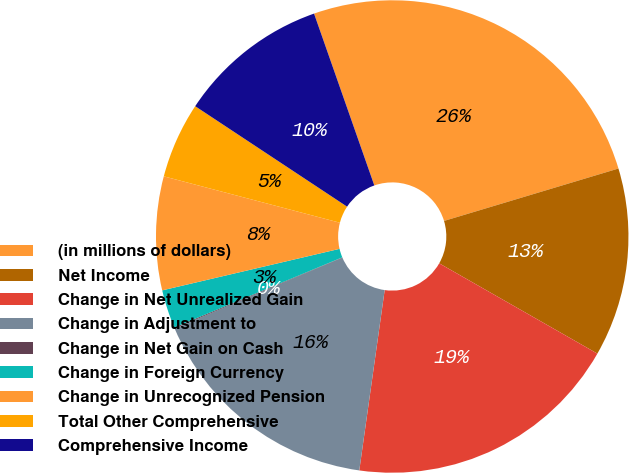Convert chart. <chart><loc_0><loc_0><loc_500><loc_500><pie_chart><fcel>(in millions of dollars)<fcel>Net Income<fcel>Change in Net Unrealized Gain<fcel>Change in Adjustment to<fcel>Change in Net Gain on Cash<fcel>Change in Foreign Currency<fcel>Change in Unrecognized Pension<fcel>Total Other Comprehensive<fcel>Comprehensive Income<nl><fcel>25.72%<fcel>12.9%<fcel>18.97%<fcel>16.41%<fcel>0.07%<fcel>2.63%<fcel>7.76%<fcel>5.2%<fcel>10.33%<nl></chart> 